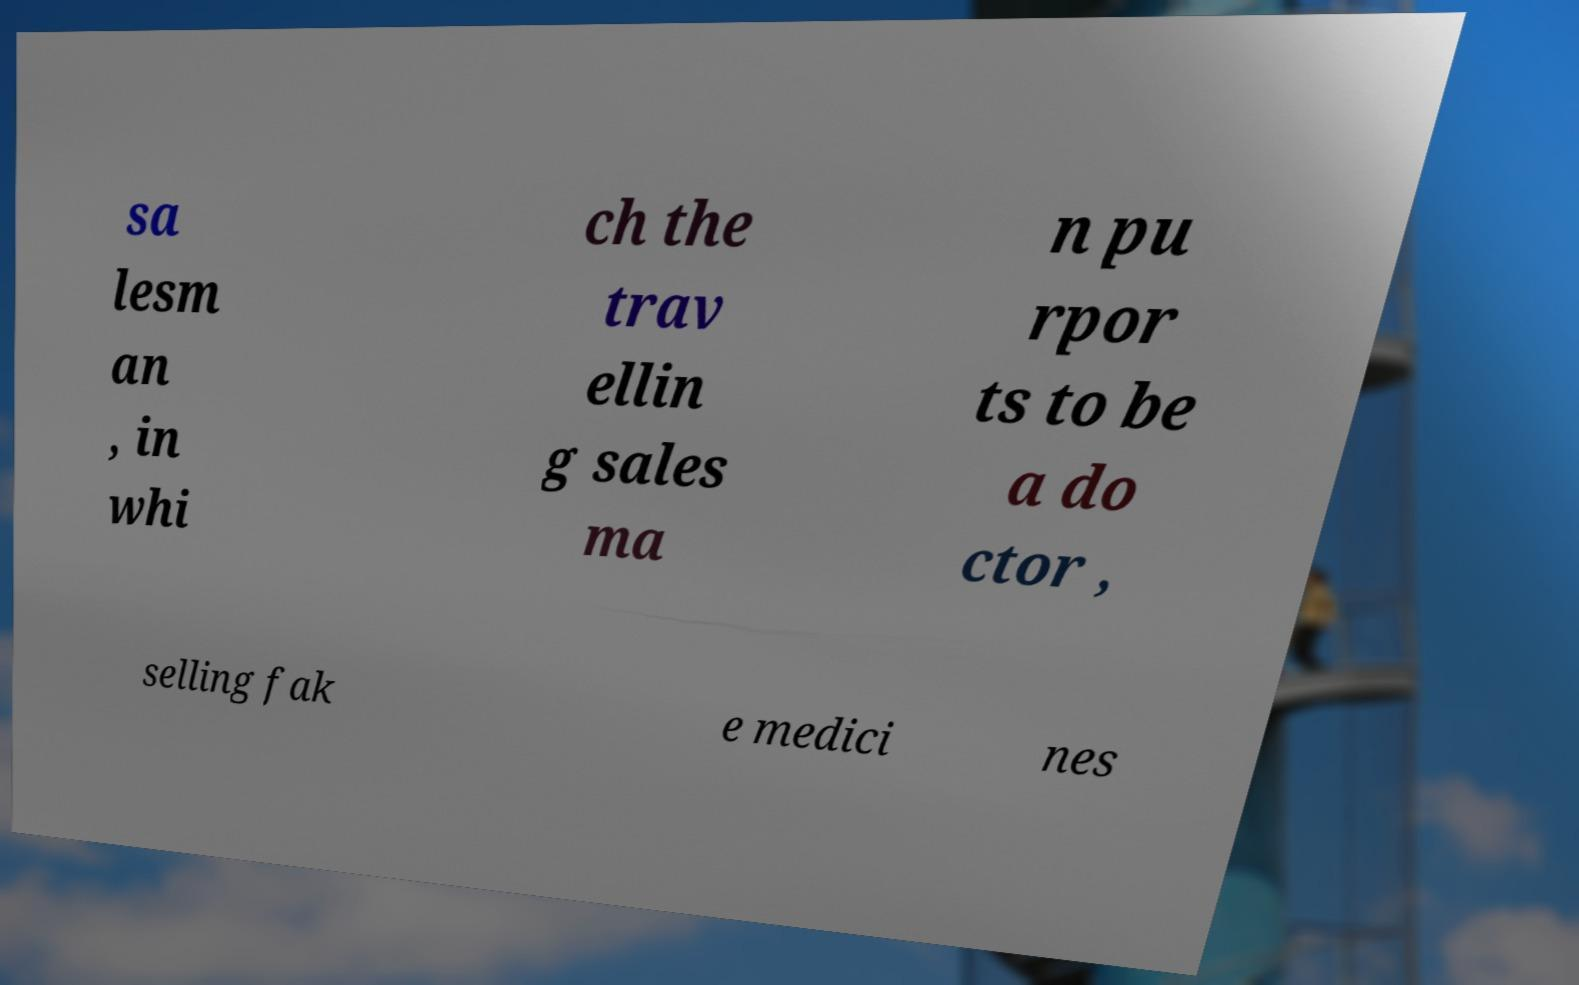Can you read and provide the text displayed in the image?This photo seems to have some interesting text. Can you extract and type it out for me? sa lesm an , in whi ch the trav ellin g sales ma n pu rpor ts to be a do ctor , selling fak e medici nes 